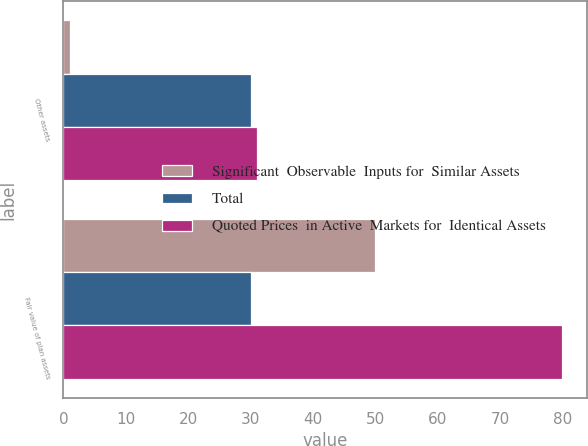Convert chart. <chart><loc_0><loc_0><loc_500><loc_500><stacked_bar_chart><ecel><fcel>Other assets<fcel>Fair value of plan assets<nl><fcel>Significant  Observable  Inputs for  Similar Assets<fcel>1<fcel>50<nl><fcel>Total<fcel>30<fcel>30<nl><fcel>Quoted Prices  in Active  Markets for  Identical Assets<fcel>31<fcel>80<nl></chart> 